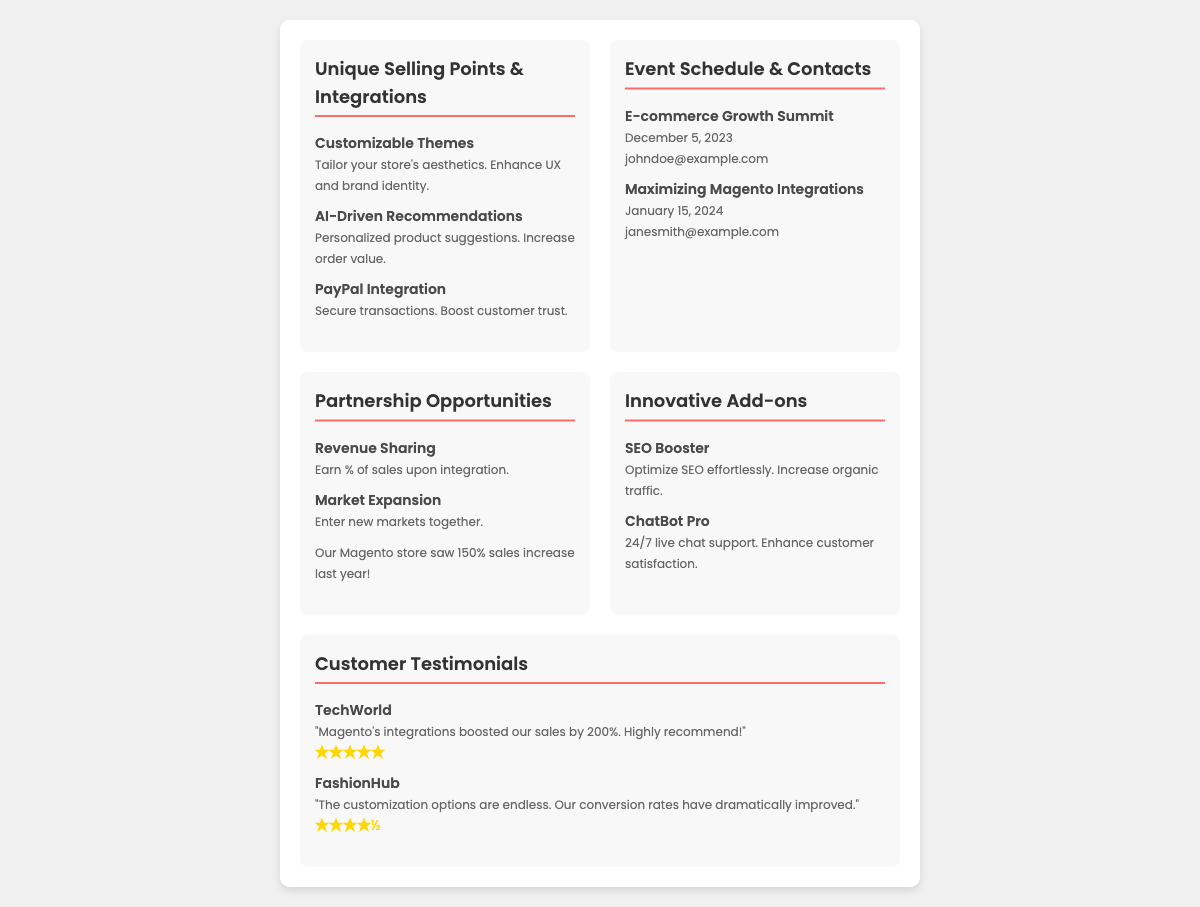What is the date of the E-commerce Growth Summit? The date of the E-commerce Growth Summit is stated in the document under the event schedule section.
Answer: December 5, 2023 What benefit is associated with revenue sharing? The document mentions revenue sharing as a benefit under partnership opportunities, specifically the earnings result from integrating services.
Answer: Earn % of sales upon integration Which add-on is designed to increase organic traffic? The add-on designed to optimize SEO and increase organic traffic is listed in the innovative add-ons section.
Answer: SEO Booster Who provided a testimonial claiming a 200% sales boost? This testimonial from TechWorld is highlighted in the customer testimonials section.
Answer: TechWorld What is the main feature that enhances customer satisfaction mentioned in the innovative add-ons? The feature that provides 24/7 support to improve customer satisfaction is found in the add-ons section of the document.
Answer: ChatBot Pro What is the email contact for the Maximizing Magento Integrations event? The document specifies the contact email for this event under the event schedule.
Answer: janesmith@example.com What percentage of sales increase did your Magento store experience last year? The document states a specific sales increase percentage for the online store, indicating its success during the last year.
Answer: 150% Which company rated the service as four and a half stars? This rating is provided in a testimonial within the customer testimonials section of the document.
Answer: FashionHub 